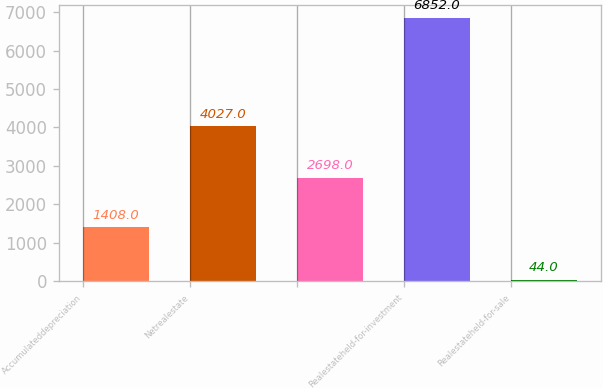Convert chart. <chart><loc_0><loc_0><loc_500><loc_500><bar_chart><fcel>Accumulateddepreciation<fcel>Netrealestate<fcel>Unnamed: 2<fcel>Realestateheld-for-investment<fcel>Realestateheld-for-sale<nl><fcel>1408<fcel>4027<fcel>2698<fcel>6852<fcel>44<nl></chart> 